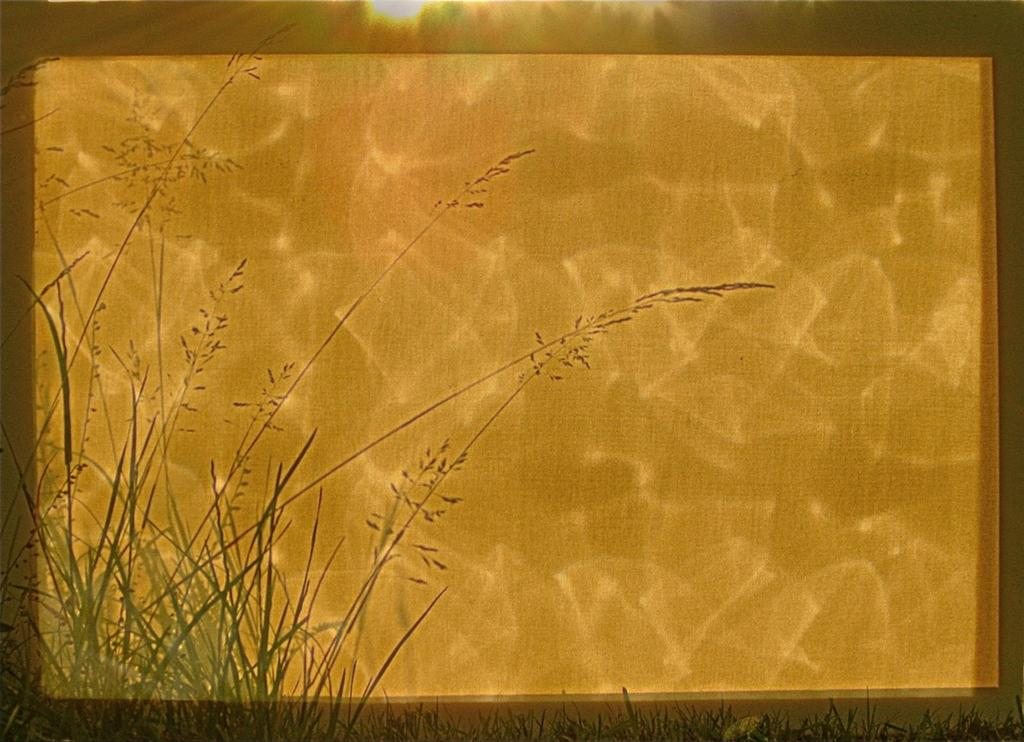What is the main subject of the image? There is a painting in the image. What elements are present in the painting? The painting contains water and grass. Can you see any fingers burning in the painting? There are no fingers or any indication of burning in the painting; it only contains water and grass. 